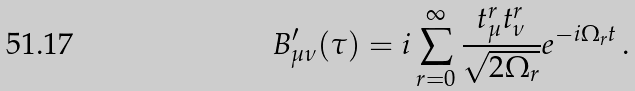Convert formula to latex. <formula><loc_0><loc_0><loc_500><loc_500>B _ { \mu \nu } ^ { \prime } ( \tau ) = i \sum _ { r = 0 } ^ { \infty } \frac { t _ { \mu } ^ { r } t _ { \nu } ^ { r } } { \sqrt { 2 \Omega _ { r } } } e ^ { - i \Omega _ { r } t } \, .</formula> 